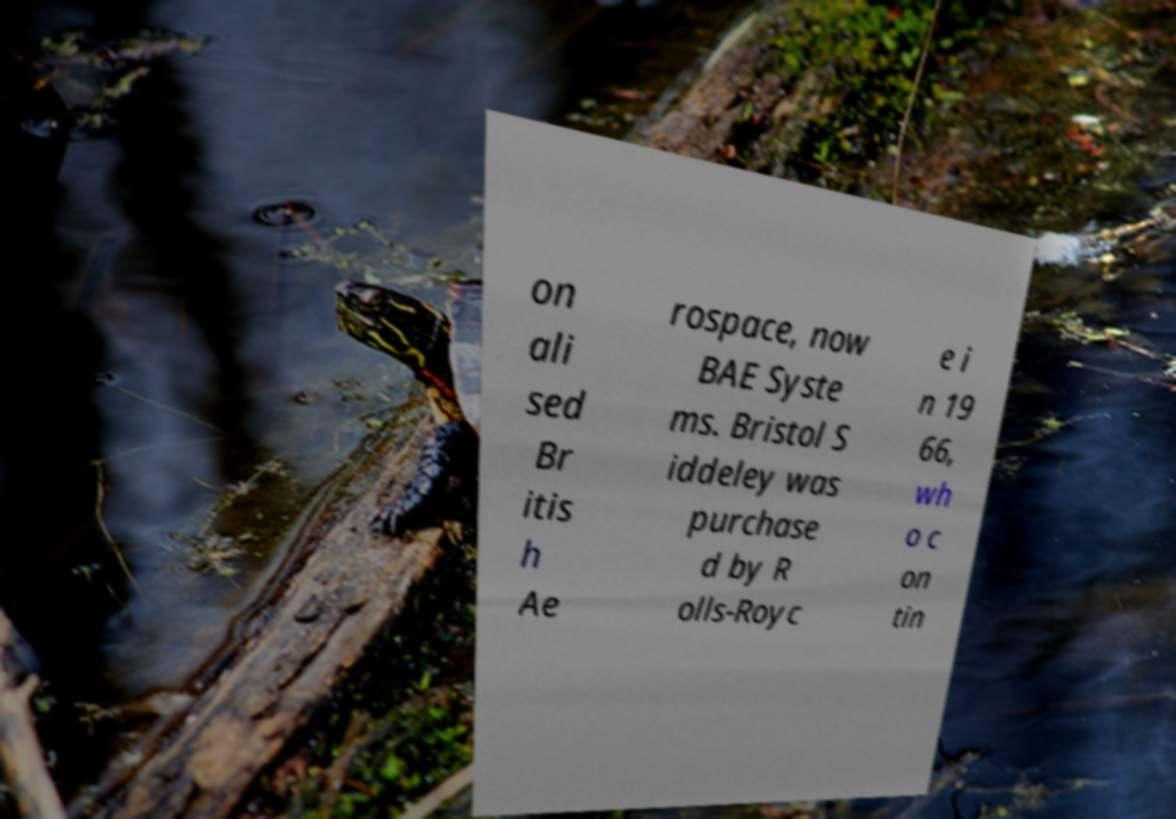Can you read and provide the text displayed in the image?This photo seems to have some interesting text. Can you extract and type it out for me? on ali sed Br itis h Ae rospace, now BAE Syste ms. Bristol S iddeley was purchase d by R olls-Royc e i n 19 66, wh o c on tin 